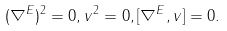<formula> <loc_0><loc_0><loc_500><loc_500>( \nabla ^ { E } ) ^ { 2 } = 0 , v ^ { 2 } = 0 , [ \nabla ^ { E } , v ] = 0 .</formula> 